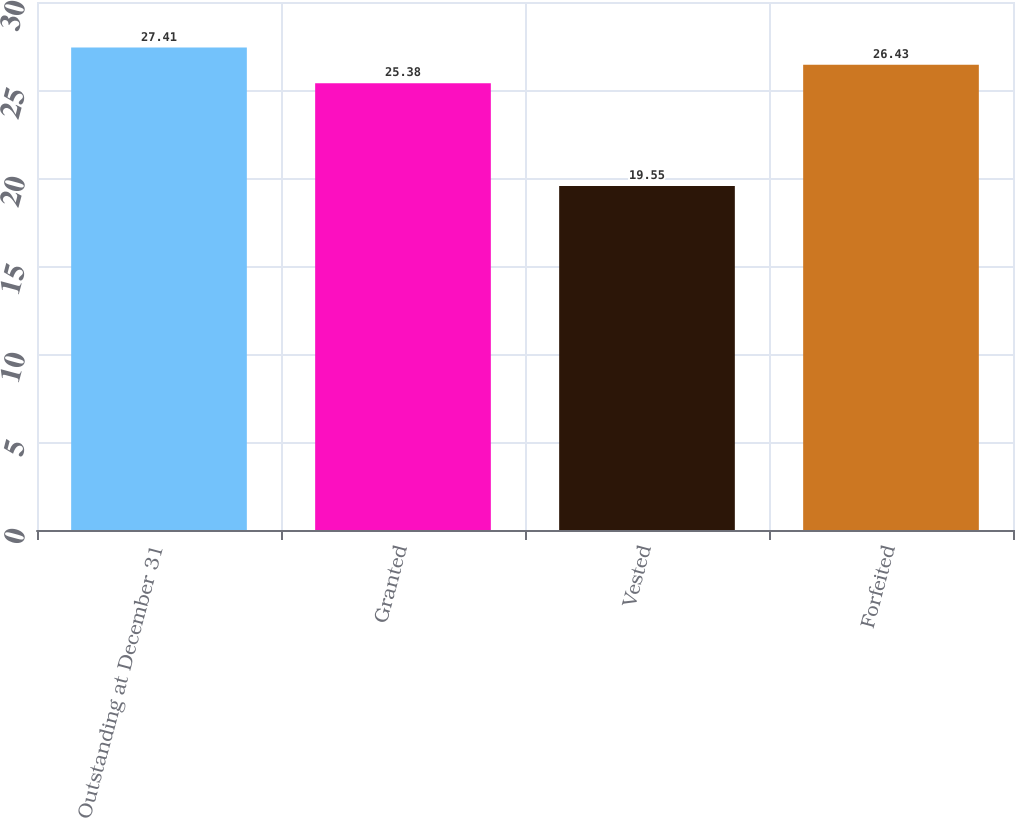Convert chart to OTSL. <chart><loc_0><loc_0><loc_500><loc_500><bar_chart><fcel>Outstanding at December 31<fcel>Granted<fcel>Vested<fcel>Forfeited<nl><fcel>27.41<fcel>25.38<fcel>19.55<fcel>26.43<nl></chart> 